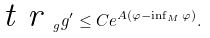Convert formula to latex. <formula><loc_0><loc_0><loc_500><loc_500>\emph { t r } _ { g } { g ^ { \prime } } \leq C e ^ { A ( \varphi - \inf _ { M } \varphi ) } .</formula> 